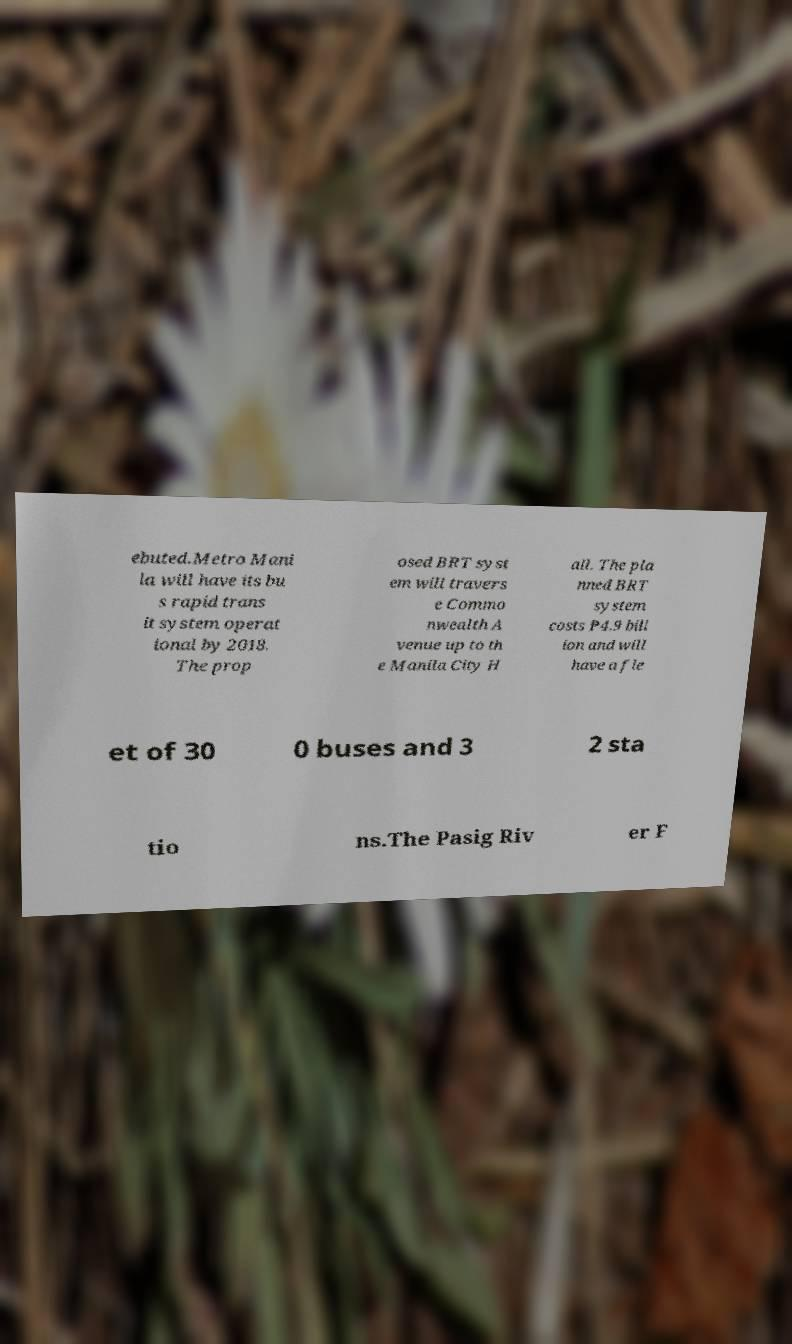Could you extract and type out the text from this image? ebuted.Metro Mani la will have its bu s rapid trans it system operat ional by 2018. The prop osed BRT syst em will travers e Commo nwealth A venue up to th e Manila City H all. The pla nned BRT system costs ₱4.9 bill ion and will have a fle et of 30 0 buses and 3 2 sta tio ns.The Pasig Riv er F 